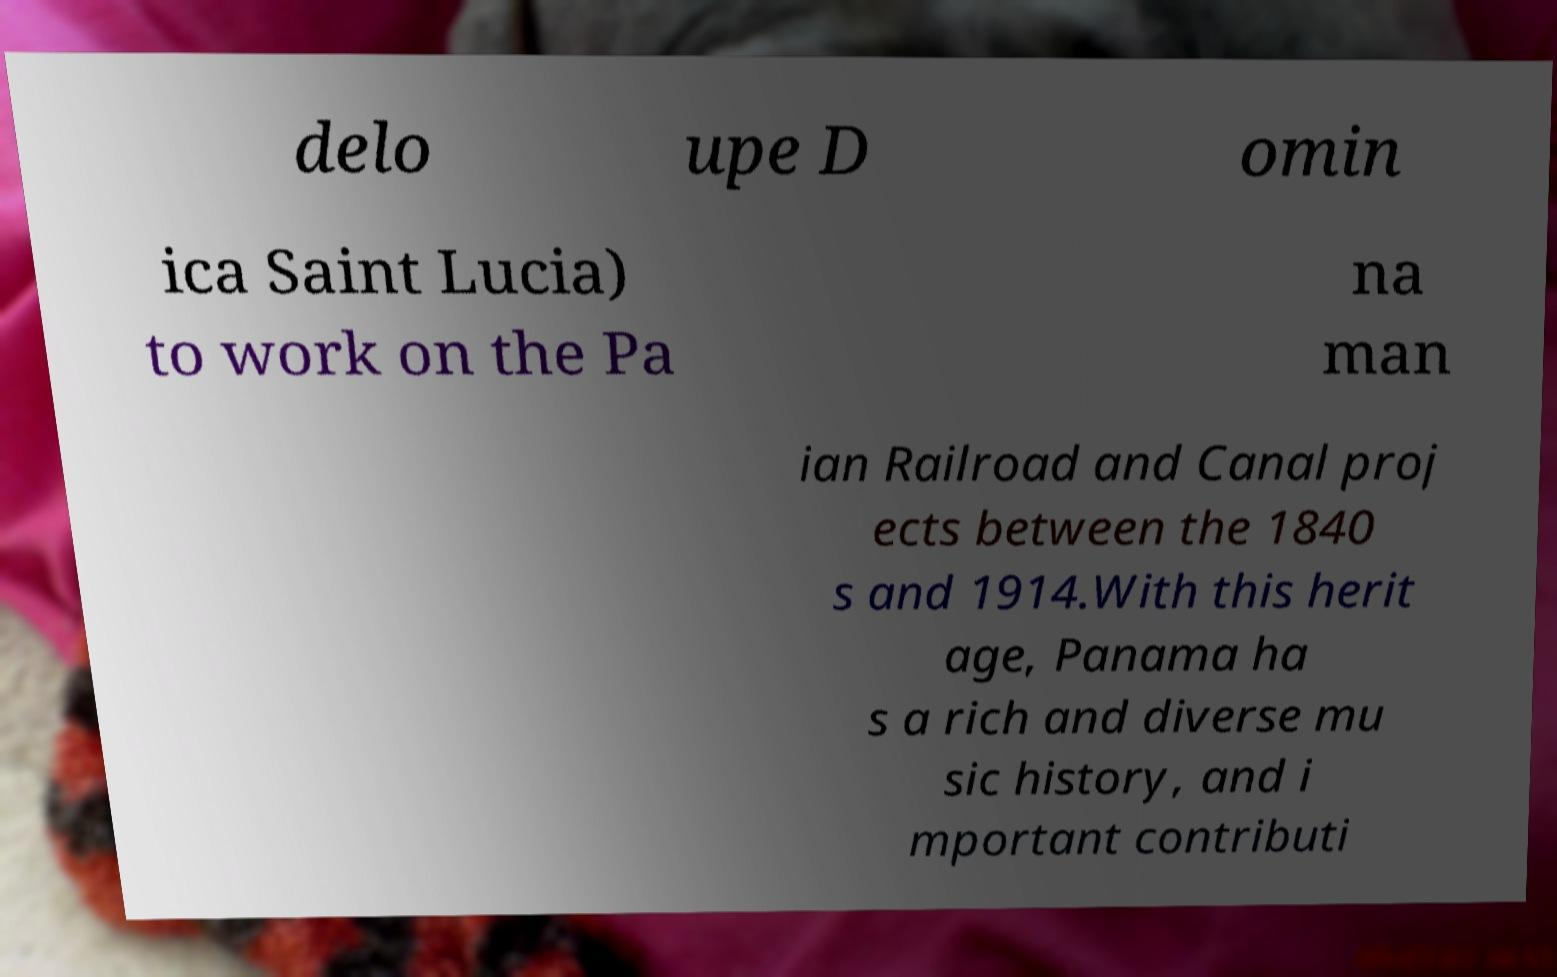Could you extract and type out the text from this image? delo upe D omin ica Saint Lucia) to work on the Pa na man ian Railroad and Canal proj ects between the 1840 s and 1914.With this herit age, Panama ha s a rich and diverse mu sic history, and i mportant contributi 